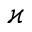Convert formula to latex. <formula><loc_0><loc_0><loc_500><loc_500>\varkappa</formula> 